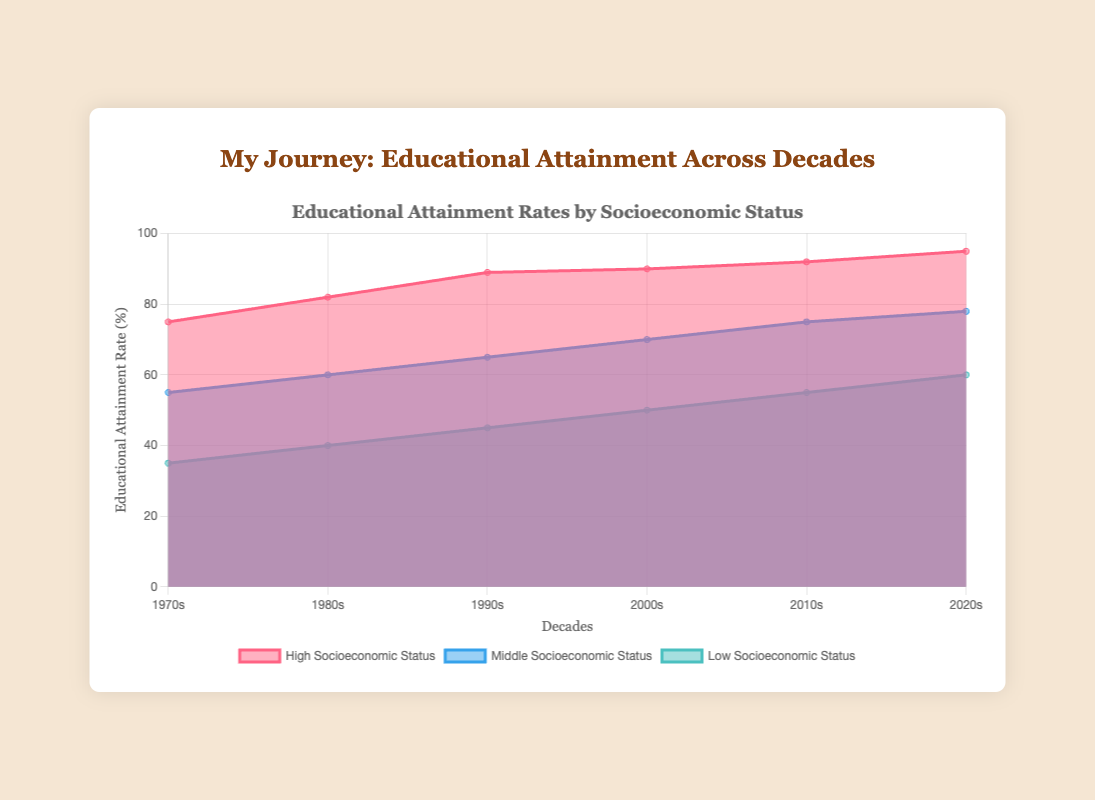What is the title of the chart? The title is displayed at the top of the chart, which is "Educational Attainment Rates by Socioeconomic Status".
Answer: Educational Attainment Rates by Socioeconomic Status Which decade shows the highest educational attainment rate for High Socioeconomic Status? The rates for High Socioeconomic Status are displayed across the decades. The highest rate is 95% in the 2020s.
Answer: 2020s What is the educational attainment rate for Low Socioeconomic Status in the 1990s? The three categories are separated by different colors. For Low Socioeconomic Status, find the data point for the 1990s and look at the required value, which is 45%.
Answer: 45% How has the educational attainment rate for Middle Socioeconomic Status changed from the 1970s to the 2020s? Locate the rates for Middle Socioeconomic Status in the 1970s (55%) and in the 2020s (78%). The change is 78% - 55% which equals 23%.
Answer: Increased by 23% In which decades did the High Socioeconomic Status group see a significant increase in educational attainment rate? Comparing the rates for High Socioeconomic Status across decades, significant increases are seen between the 1980s (82%) and 1990s (89%), and between the 2010s (92%) and 2020s (95%).
Answer: 1980s to 1990s, 2010s to 2020s Compare the educational attainment rates of Middle and Low Socioeconomic Status in the 2000s. For the 2000s, Middle Socioeconomic Status shows a rate of 70%, and Low Socioeconomic Status is 50%.
Answer: Middle: 70%, Low: 50% What is the trend in the educational attainment rate for the Low Socioeconomic Status group from the 1970s to the 2020s? Observing the rates for Low Socioeconomic Status, the trend is consistently increasing from 35% in the 1970s to 60% in the 2020s.
Answer: Increasing What is the average educational attainment rate for all socioeconomic groups in the 2010s? Adding the rates (55% + 75% + 92%) and dividing by the number of groups (3) provides the average: (55 + 75 + 92)/3 = 74%.
Answer: 74% Which socioeconomic status group has the least variation in educational attainment rates across decades? Assessing the data, the High Socioeconomic Status group goes from 75% to 95%, totaling a 20% change. Comparing this with others shows the Middle (23%) and Low (25%) have more variation.
Answer: High Socioeconomic Status 